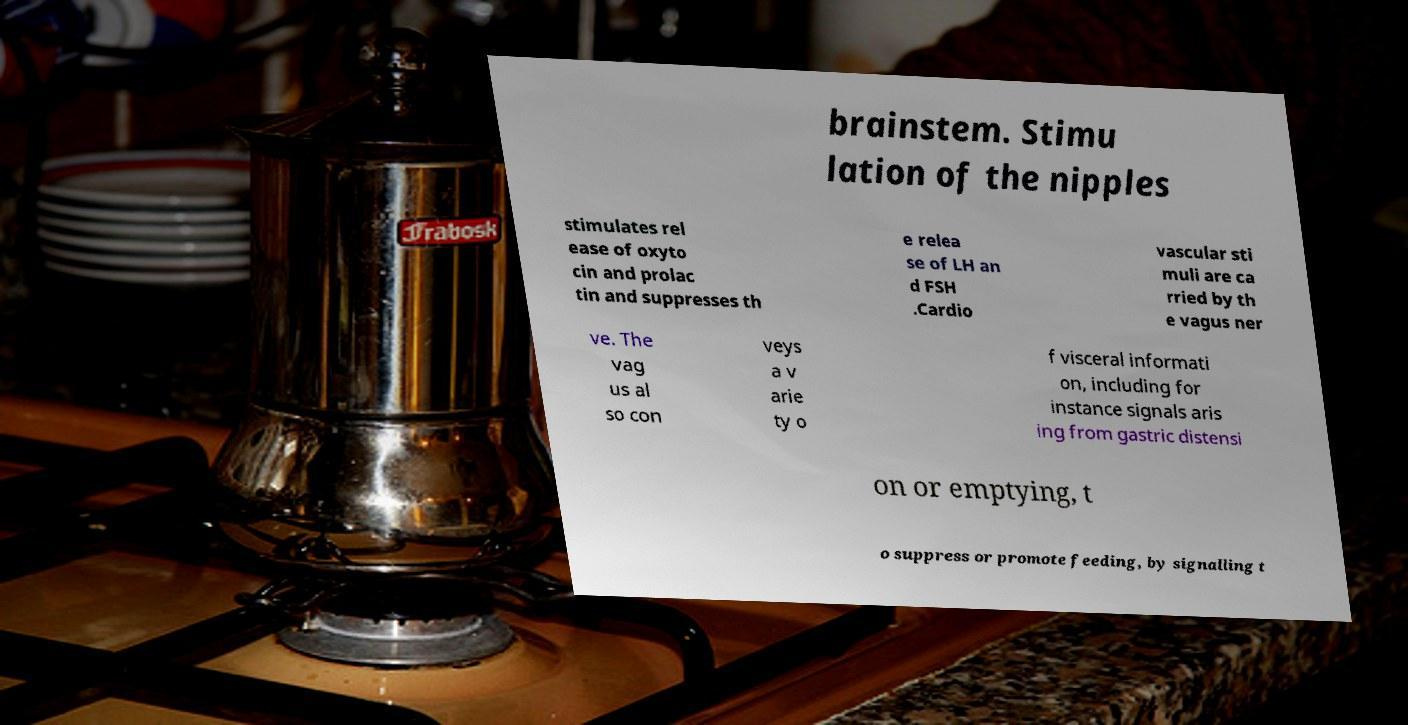Could you assist in decoding the text presented in this image and type it out clearly? brainstem. Stimu lation of the nipples stimulates rel ease of oxyto cin and prolac tin and suppresses th e relea se of LH an d FSH .Cardio vascular sti muli are ca rried by th e vagus ner ve. The vag us al so con veys a v arie ty o f visceral informati on, including for instance signals aris ing from gastric distensi on or emptying, t o suppress or promote feeding, by signalling t 